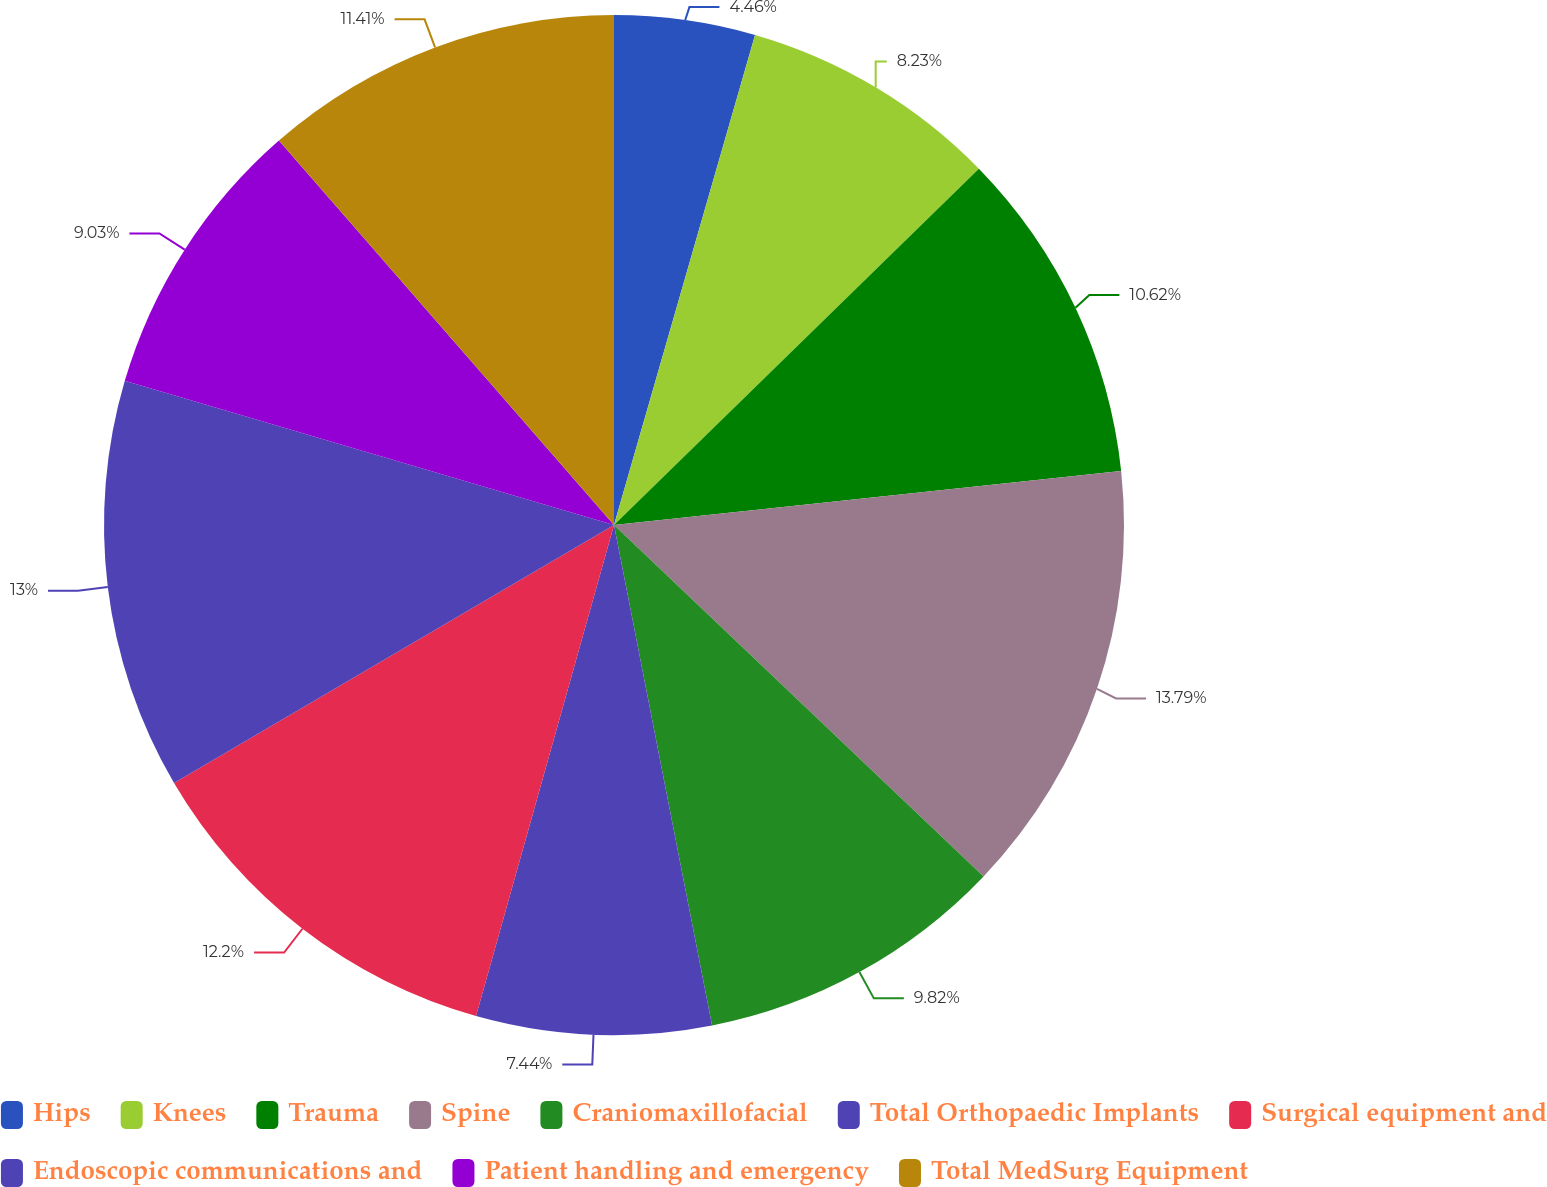Convert chart. <chart><loc_0><loc_0><loc_500><loc_500><pie_chart><fcel>Hips<fcel>Knees<fcel>Trauma<fcel>Spine<fcel>Craniomaxillofacial<fcel>Total Orthopaedic Implants<fcel>Surgical equipment and<fcel>Endoscopic communications and<fcel>Patient handling and emergency<fcel>Total MedSurg Equipment<nl><fcel>4.46%<fcel>8.23%<fcel>10.62%<fcel>13.79%<fcel>9.82%<fcel>7.44%<fcel>12.2%<fcel>13.0%<fcel>9.03%<fcel>11.41%<nl></chart> 